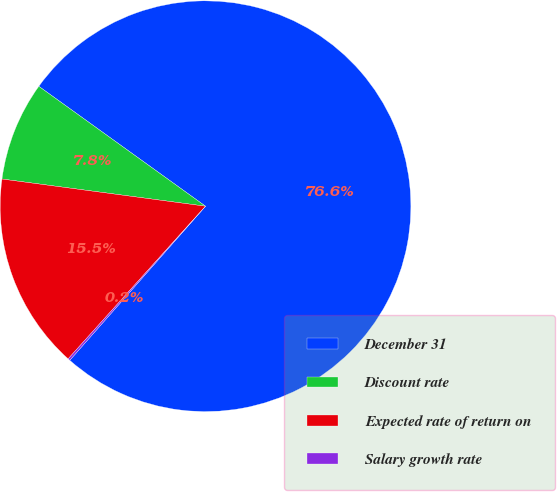Convert chart to OTSL. <chart><loc_0><loc_0><loc_500><loc_500><pie_chart><fcel>December 31<fcel>Discount rate<fcel>Expected rate of return on<fcel>Salary growth rate<nl><fcel>76.57%<fcel>7.81%<fcel>15.45%<fcel>0.17%<nl></chart> 